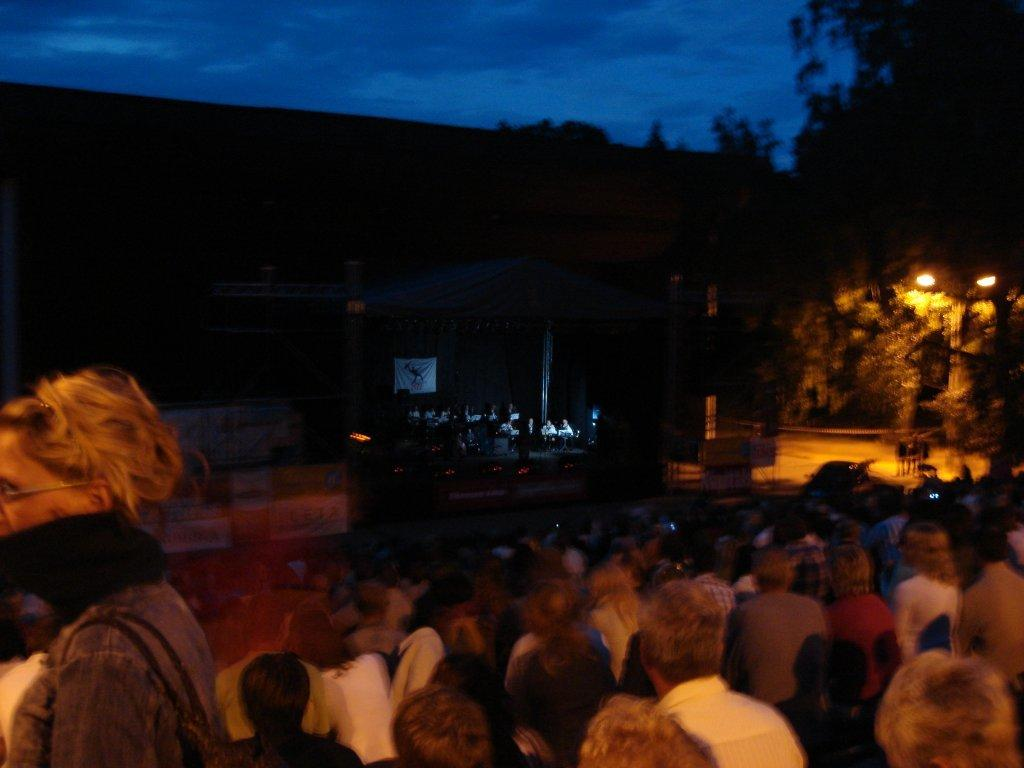How many people are in the image? There is a group of persons in the image. What can be seen on the right side of the image? There are trees on the right side of the image. What is attached to the pole in the image? The pole has lights attached to it. What is the color of the background in the image? The background of the image is dark. What is visible at the top of the image? The sky is visible at the top of the image. How much money is being exchanged between the persons in the image? There is no indication of money exchange in the image. What type of sack is being used by the persons in the image? There is no sack visible in the image. 